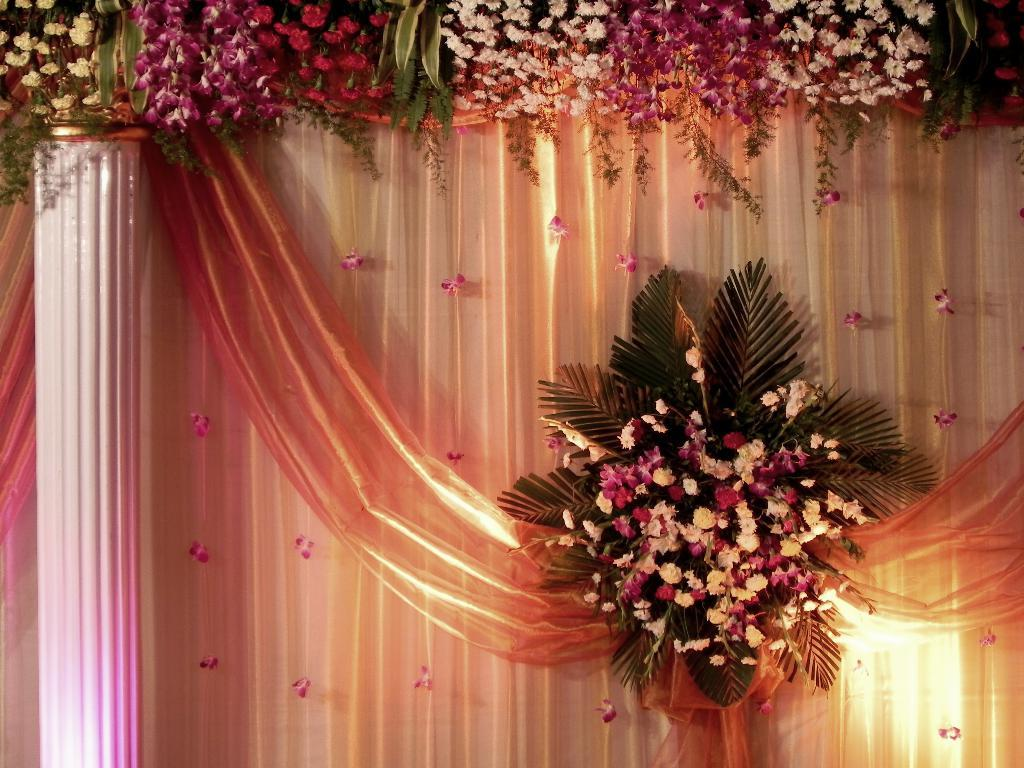What is the main subject of the image? There is a bouquet in the image. What type of flowers can be seen in the image? There are flowers visible in the image. What architectural feature is present in the image? There is a pillar in the image. What can be seen in the background of the image? There is cloth in the background of the image. What type of brick is used to construct the pillar in the image? There is no brick visible in the image, as the pillar is not made of brick. 